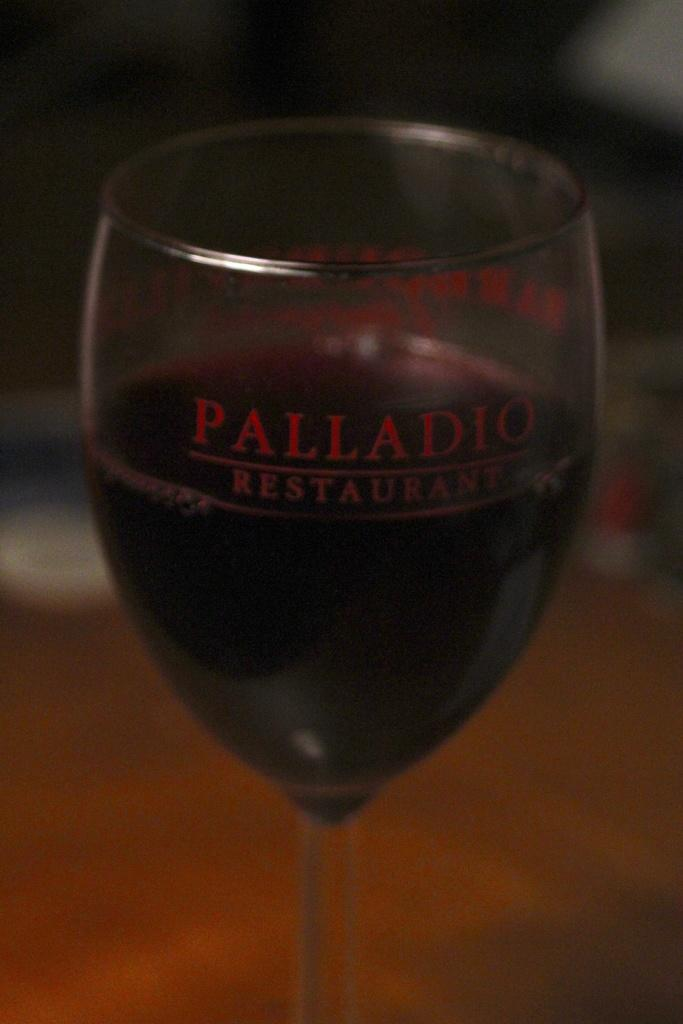What is contained in the glass that is visible in the image? There is a drink in the glass in the image. Can you describe the background of the image? The background of the image is blurry. What year is depicted in the image? There is no indication of a specific year in the image. Can you see any ducks or waves in the image? There are no ducks or waves present in the image. 